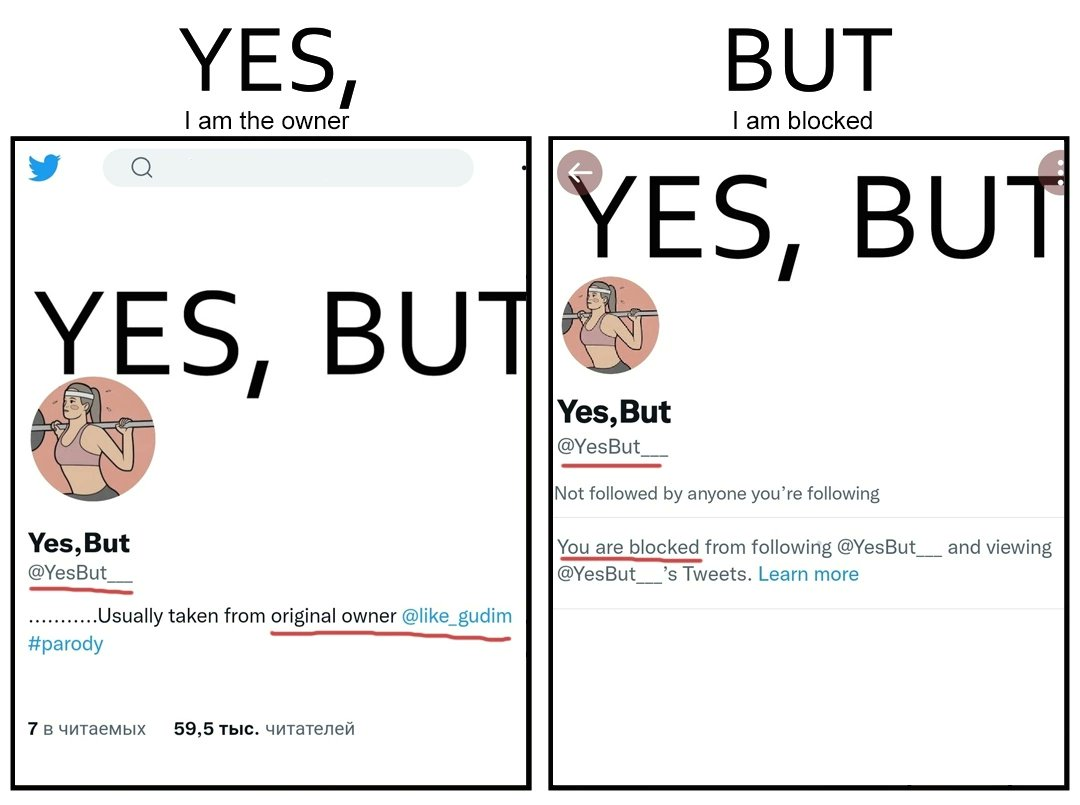Provide a description of this image. The images are ironic since while the page "Yes, But" credits the original creator "@like_gudim" for its posts, the page "Yes, But" has blocked "@like_gudim" from following the page 